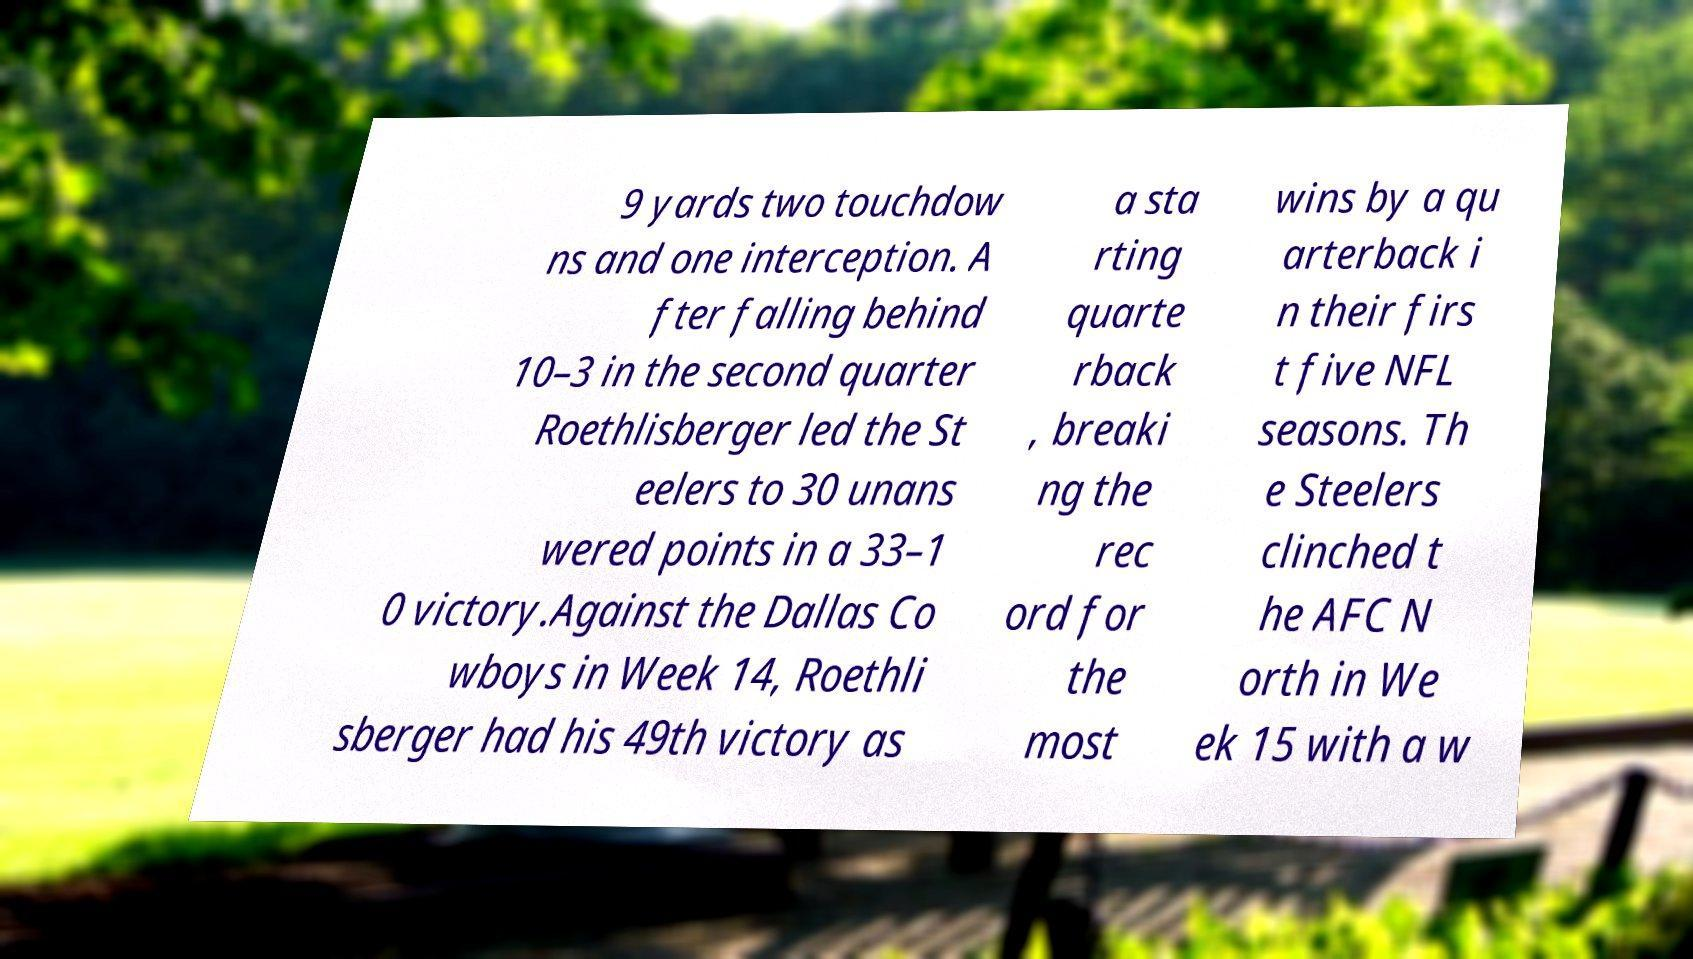Could you extract and type out the text from this image? 9 yards two touchdow ns and one interception. A fter falling behind 10–3 in the second quarter Roethlisberger led the St eelers to 30 unans wered points in a 33–1 0 victory.Against the Dallas Co wboys in Week 14, Roethli sberger had his 49th victory as a sta rting quarte rback , breaki ng the rec ord for the most wins by a qu arterback i n their firs t five NFL seasons. Th e Steelers clinched t he AFC N orth in We ek 15 with a w 